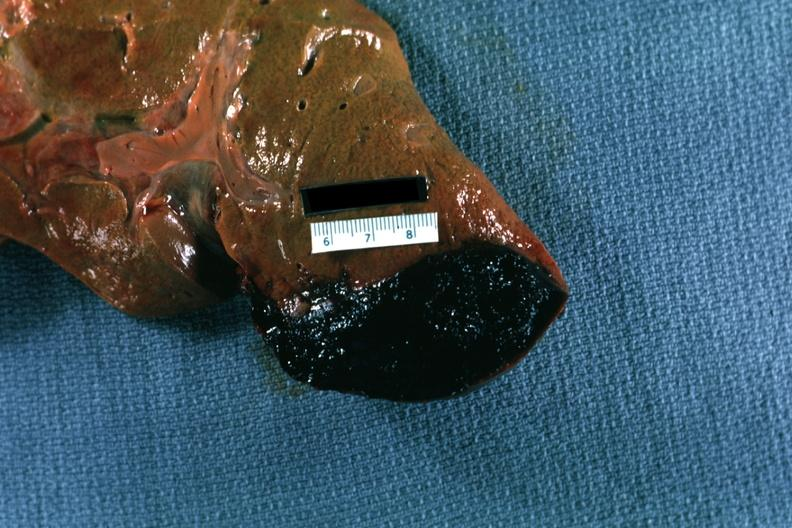what is present?
Answer the question using a single word or phrase. Hepatobiliary 